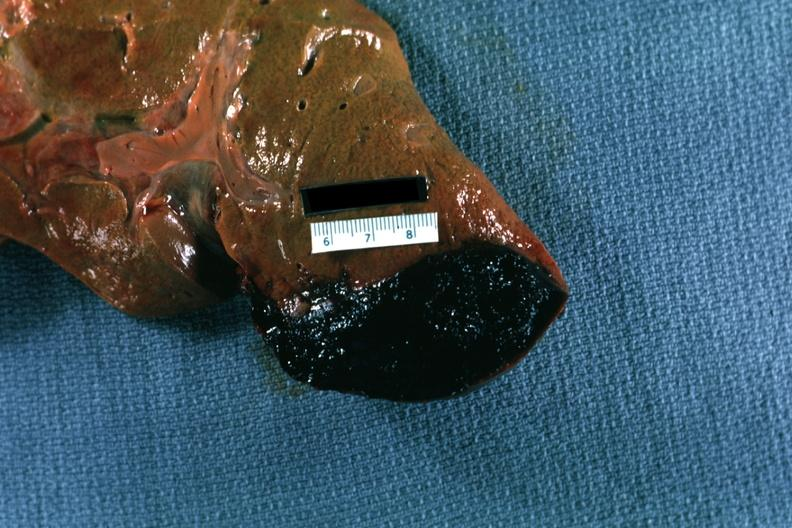what is present?
Answer the question using a single word or phrase. Hepatobiliary 